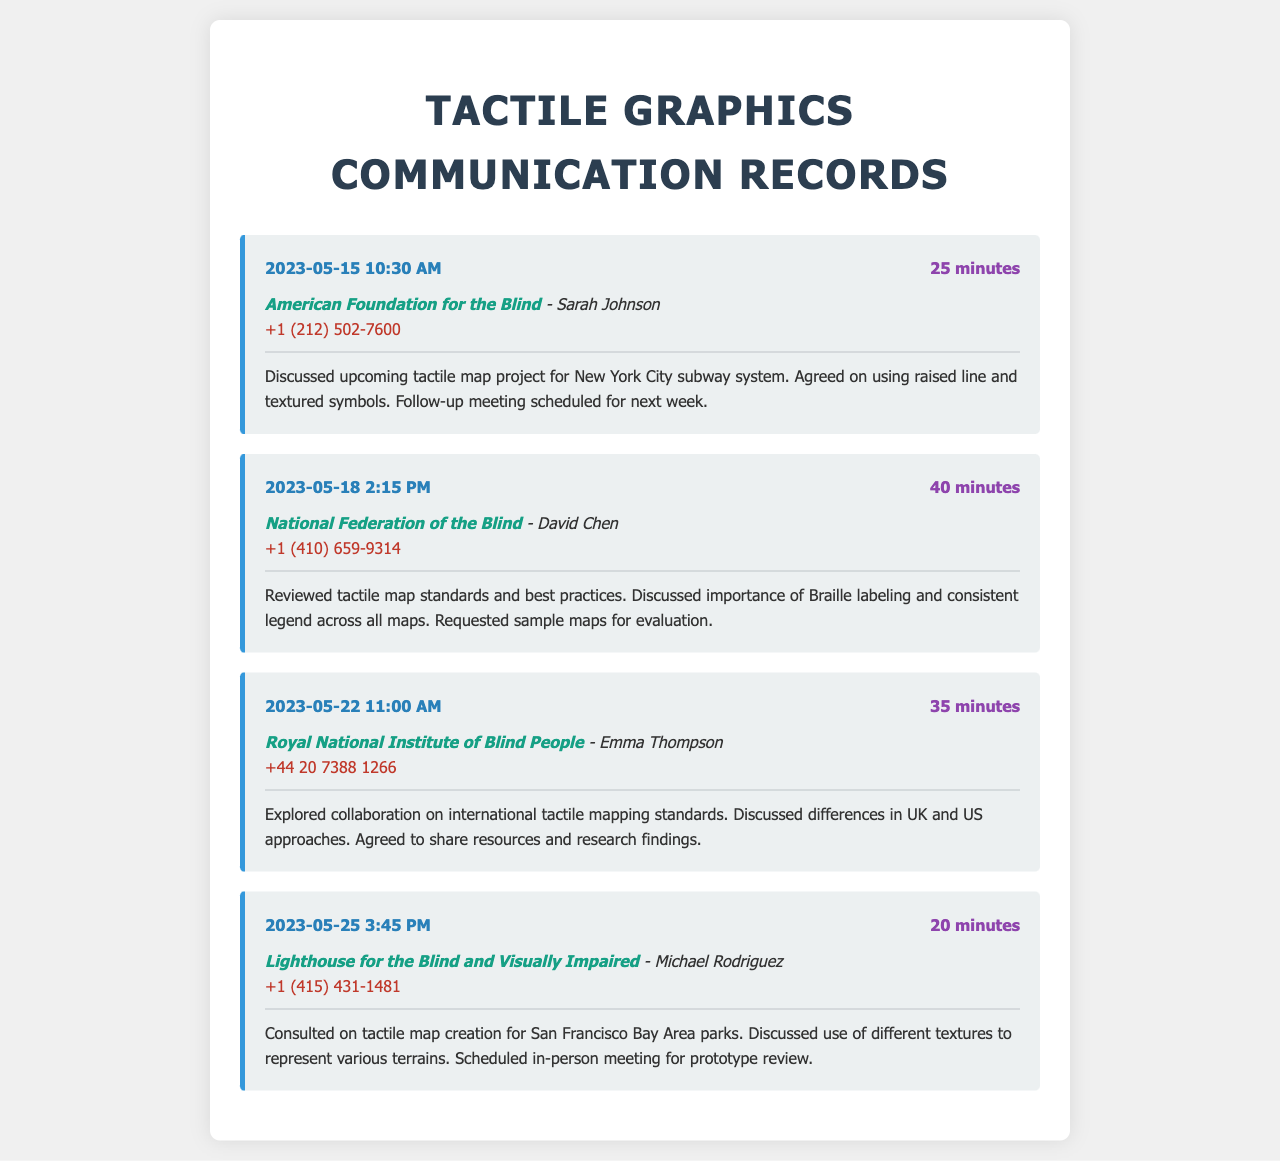what was the date of the first communication? The date of the first communication recorded in the document is found in the first entry, which mentions "2023-05-15."
Answer: 2023-05-15 who was the contact person for the American Foundation for the Blind? The contact person for the American Foundation for the Blind is specified in the first record, under contact information as "Sarah Johnson."
Answer: Sarah Johnson how many minutes was the call with the National Federation of the Blind? The duration of the call with the National Federation of the Blind is noted in the second record as "40 minutes."
Answer: 40 minutes which organization was discussed on May 25, 2023? The organization discussed on May 25, 2023, can be found in the fourth record, which mentions "Lighthouse for the Blind and Visually Impaired."
Answer: Lighthouse for the Blind and Visually Impaired what type of project was discussed with the American Foundation for the Blind? The project type discussed with the American Foundation for the Blind is detailed in the summary of the first record, mentioning "tactile map project for New York City subway system."
Answer: tactile map project for New York City subway system what was the purpose of the call on May 22, 2023? The purpose of the call on May 22, 2023, is outlined in the third record, which discusses "collaboration on international tactile mapping standards."
Answer: collaboration on international tactile mapping standards how many records mention the use of textures? The records mentioning the use of textures can be found in the first and fourth entries, thus counting these gives a total of two.
Answer: 2 what was the follow-up action agreed with the American Foundation for the Blind? The follow-up action agreed upon with the American Foundation for the Blind is indicated in the summary of the first record as "Follow-up meeting scheduled for next week."
Answer: Follow-up meeting scheduled for next week who requested sample maps during their call? The request for sample maps is specified in the summary of the second record where it states "Requested sample maps for evaluation."
Answer: Requested sample maps for evaluation 